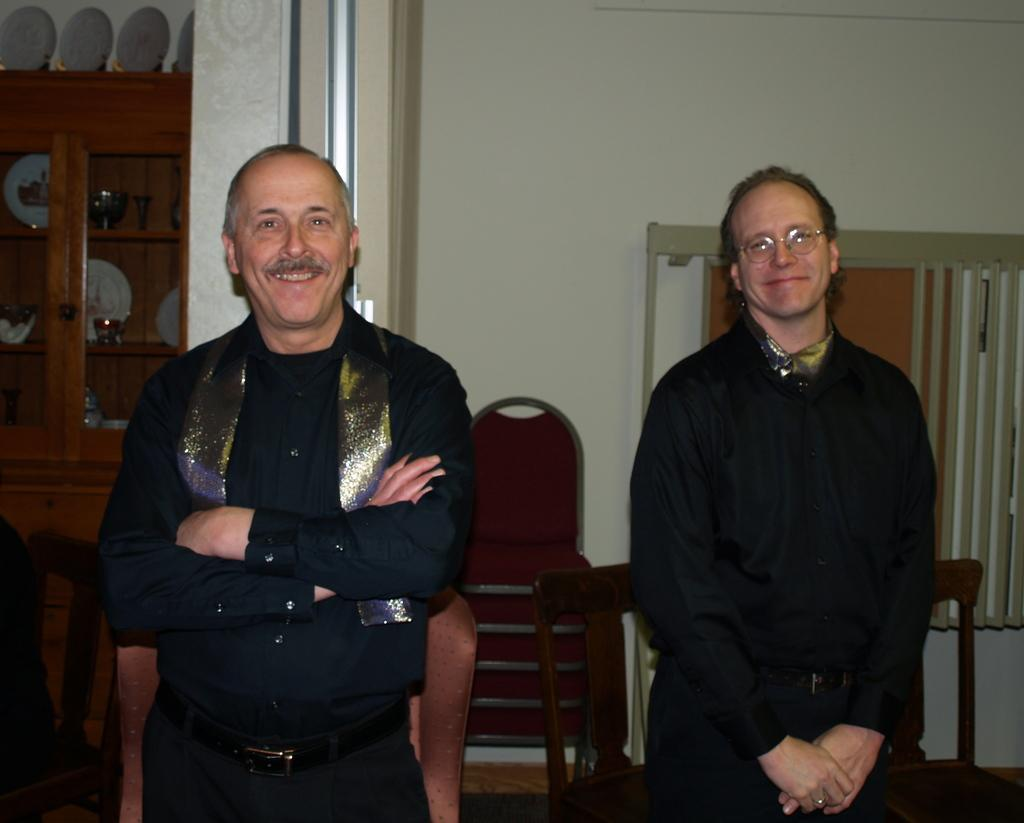How many people are present in the image? There are two men standing in the image. What objects can be seen in the image besides the men? There are chairs in the image. What type of background is visible in the image? There is a wall in the image. Where is the heart located in the image? There is no heart present in the image. Is there a bed visible in the image? No, there is no bed visible in the image. 